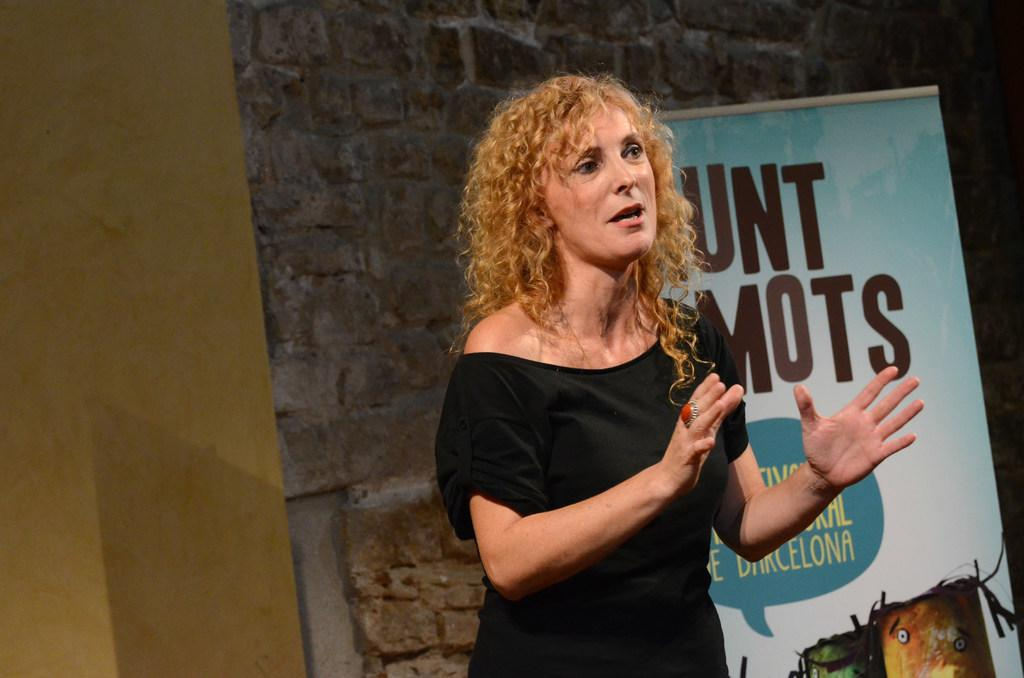What is the main subject of the image? There is a person standing in the image. What is the person doing in the image? The person is talking. What can be seen in the background of the image? There is a banner in the background of the image. What is written or depicted on the banner? The banner has text and an image on it. Where is the banner located in relation to the wall? The banner is near a wall. What type of zinc is being used to create the banner in the image? There is no information about the material used to create the banner in the image. How does the person use the whip in the image? There is no whip present in the image. 